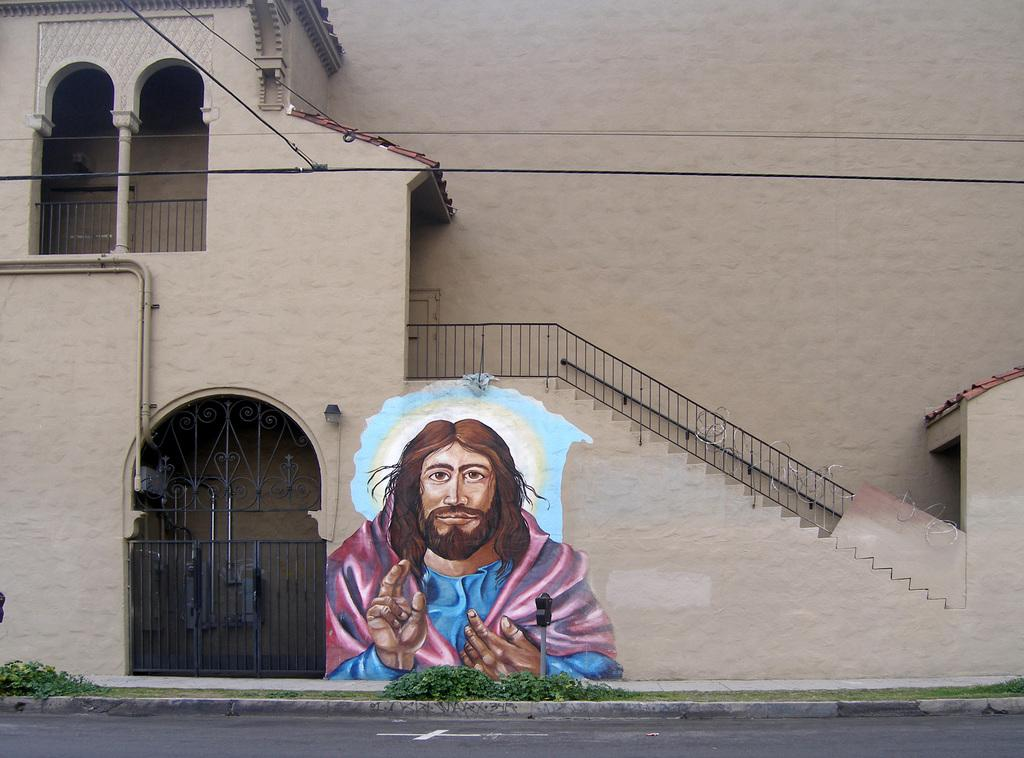What type of structure is visible in the picture? There is a house in the picture. What is located in front of the house? There is a gate in front of the house. What can be seen on the wall beside the gate? There is a painting of Jesus on the wall beside the gate. What is the setting of the house in the picture? There is a road in front of the building. What type of owl can be seen on the side of the house in the image? There is no owl present on the side of the house in the image. 